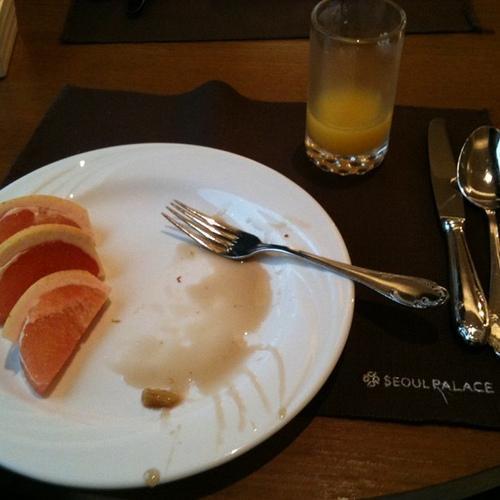How many slices of fruit are visible on the plate?
Give a very brief answer. 3. 